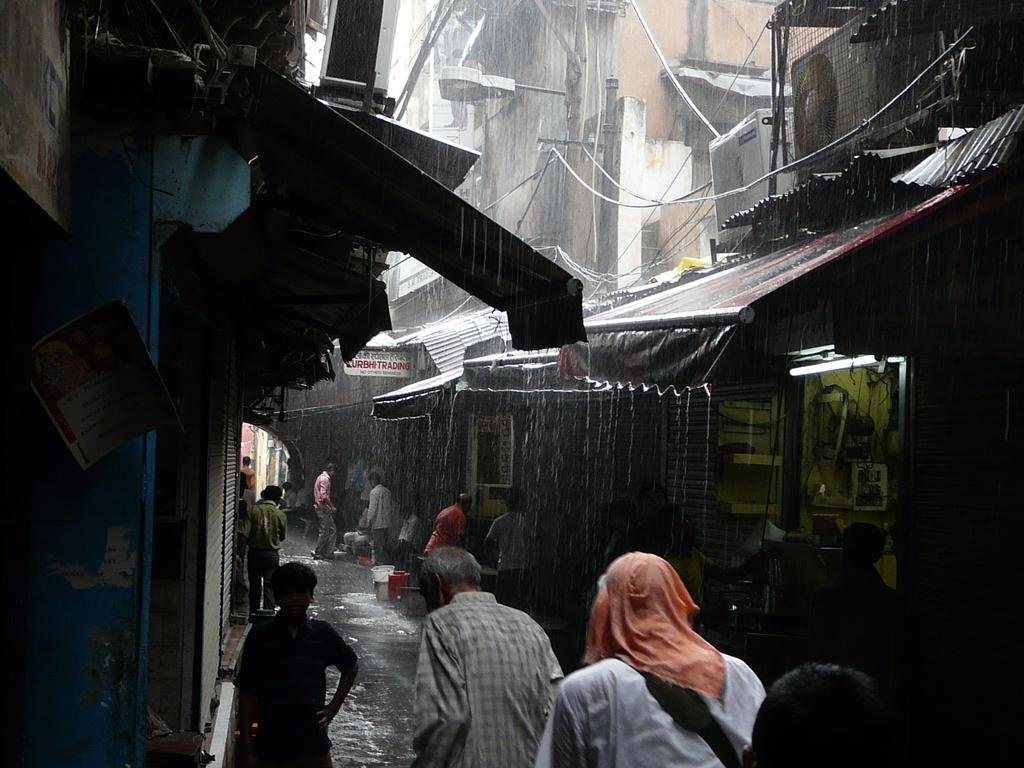Who or what can be seen in the image? There are people in the image. What type of establishments are present in the image? There are shops in the image. What type of lighting is present in the image? A street light is visible in the image. What type of infrastructure is present in the image? Electrical poles are present in the image. What type of utility is present in the image? Cable wires are visible in the image. What type of objects are present in the image? Electronic objects are present in the image. What type of signage is present in the image? There is written text on a board in the image. What type of natural element is present in the image? There is water visible in the image. What type of train can be seen driving through the water in the image? There is no train present in the image, nor is there any driving through the water. 